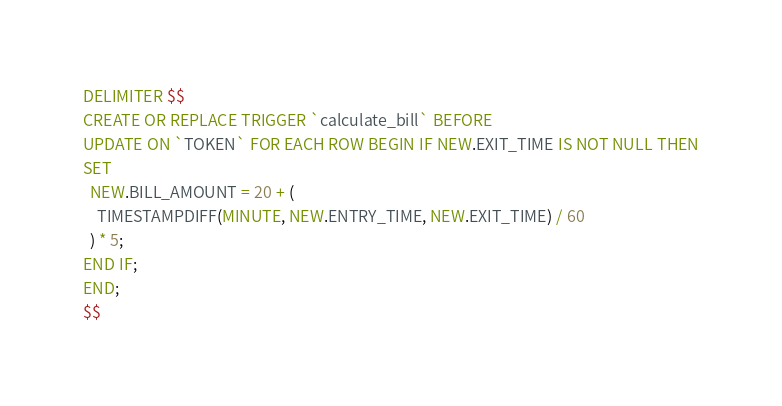<code> <loc_0><loc_0><loc_500><loc_500><_SQL_>DELIMITER $$
CREATE OR REPLACE TRIGGER `calculate_bill` BEFORE
UPDATE ON `TOKEN` FOR EACH ROW BEGIN IF NEW.EXIT_TIME IS NOT NULL THEN
SET
  NEW.BILL_AMOUNT = 20 + (
    TIMESTAMPDIFF(MINUTE, NEW.ENTRY_TIME, NEW.EXIT_TIME) / 60
  ) * 5;
END IF;
END;
$$
</code> 